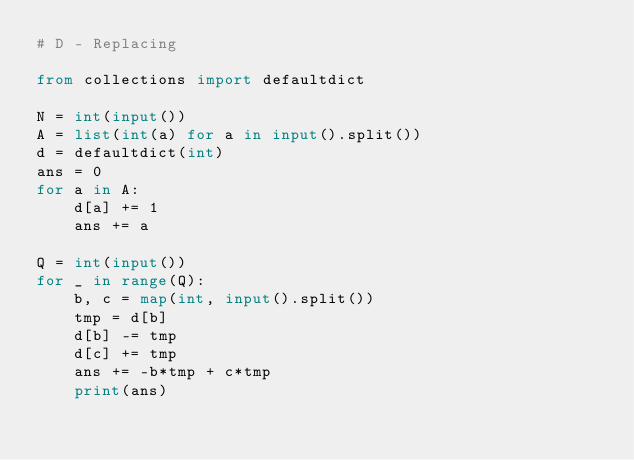<code> <loc_0><loc_0><loc_500><loc_500><_Python_># D - Replacing

from collections import defaultdict

N = int(input())
A = list(int(a) for a in input().split())
d = defaultdict(int)
ans = 0
for a in A:
    d[a] += 1
    ans += a

Q = int(input())
for _ in range(Q):
    b, c = map(int, input().split())
    tmp = d[b]
    d[b] -= tmp
    d[c] += tmp
    ans += -b*tmp + c*tmp
    print(ans)</code> 